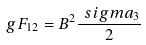<formula> <loc_0><loc_0><loc_500><loc_500>g { F } _ { 1 2 } = B ^ { 2 } { \frac { \boldmath \ s i g m a _ { 3 } } { 2 } }</formula> 